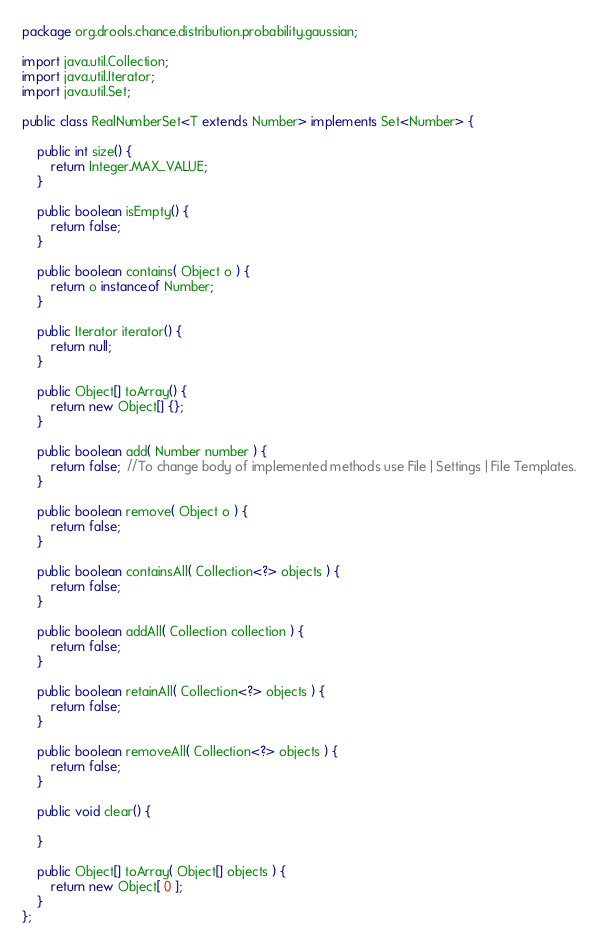Convert code to text. <code><loc_0><loc_0><loc_500><loc_500><_Java_>package org.drools.chance.distribution.probability.gaussian;

import java.util.Collection;
import java.util.Iterator;
import java.util.Set;

public class RealNumberSet<T extends Number> implements Set<Number> {

    public int size() {
        return Integer.MAX_VALUE;
    }

    public boolean isEmpty() {
        return false;
    }

    public boolean contains( Object o ) {
        return o instanceof Number;
    }

    public Iterator iterator() {
        return null;
    }

    public Object[] toArray() {
        return new Object[] {};
    }

    public boolean add( Number number ) {
        return false;  //To change body of implemented methods use File | Settings | File Templates.
    }

    public boolean remove( Object o ) {
        return false;
    }

    public boolean containsAll( Collection<?> objects ) {
        return false;
    }

    public boolean addAll( Collection collection ) {
        return false;
    }

    public boolean retainAll( Collection<?> objects ) {
        return false;
    }

    public boolean removeAll( Collection<?> objects ) {
        return false;
    }

    public void clear() {

    }

    public Object[] toArray( Object[] objects ) {
        return new Object[ 0 ];
    }
};

</code> 